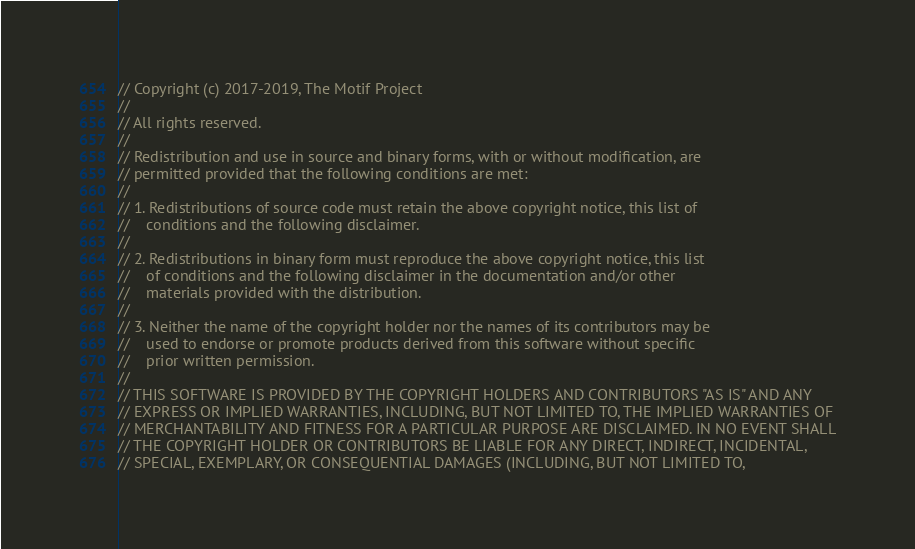<code> <loc_0><loc_0><loc_500><loc_500><_C++_>// Copyright (c) 2017-2019, The Motif Project
//
// All rights reserved.
//
// Redistribution and use in source and binary forms, with or without modification, are
// permitted provided that the following conditions are met:
//
// 1. Redistributions of source code must retain the above copyright notice, this list of
//    conditions and the following disclaimer.
//
// 2. Redistributions in binary form must reproduce the above copyright notice, this list
//    of conditions and the following disclaimer in the documentation and/or other
//    materials provided with the distribution.
//
// 3. Neither the name of the copyright holder nor the names of its contributors may be
//    used to endorse or promote products derived from this software without specific
//    prior written permission.
//
// THIS SOFTWARE IS PROVIDED BY THE COPYRIGHT HOLDERS AND CONTRIBUTORS "AS IS" AND ANY
// EXPRESS OR IMPLIED WARRANTIES, INCLUDING, BUT NOT LIMITED TO, THE IMPLIED WARRANTIES OF
// MERCHANTABILITY AND FITNESS FOR A PARTICULAR PURPOSE ARE DISCLAIMED. IN NO EVENT SHALL
// THE COPYRIGHT HOLDER OR CONTRIBUTORS BE LIABLE FOR ANY DIRECT, INDIRECT, INCIDENTAL,
// SPECIAL, EXEMPLARY, OR CONSEQUENTIAL DAMAGES (INCLUDING, BUT NOT LIMITED TO,</code> 